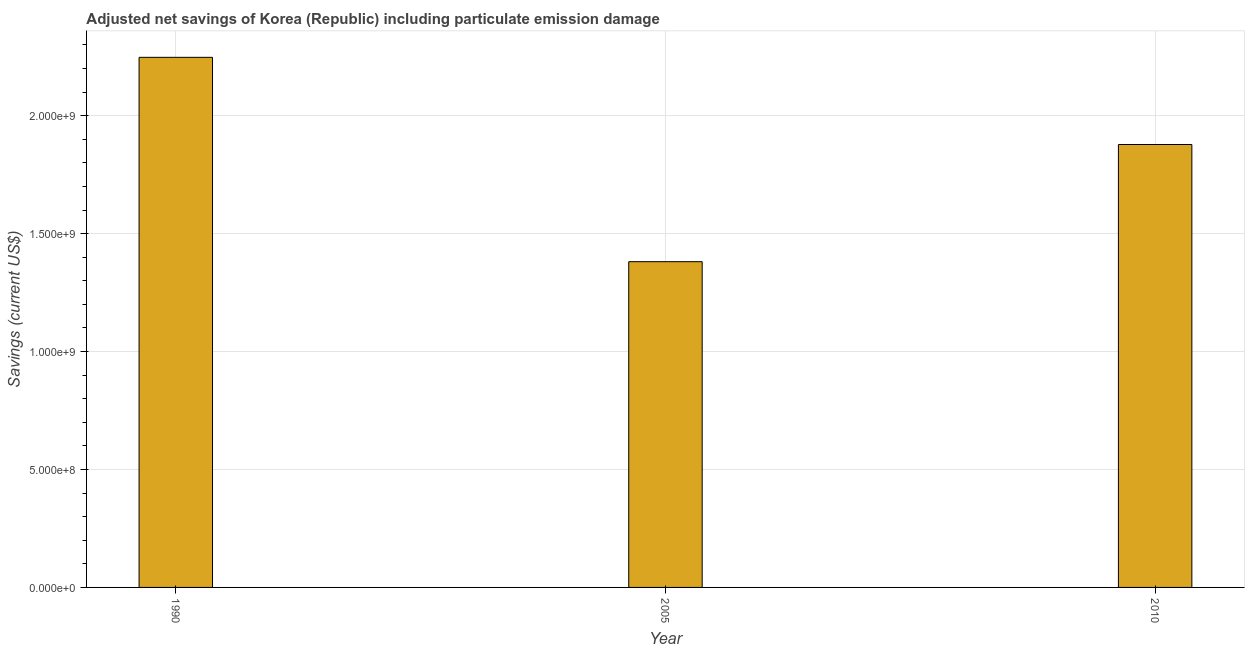Does the graph contain any zero values?
Ensure brevity in your answer.  No. What is the title of the graph?
Offer a very short reply. Adjusted net savings of Korea (Republic) including particulate emission damage. What is the label or title of the Y-axis?
Offer a terse response. Savings (current US$). What is the adjusted net savings in 2010?
Provide a short and direct response. 1.88e+09. Across all years, what is the maximum adjusted net savings?
Provide a succinct answer. 2.25e+09. Across all years, what is the minimum adjusted net savings?
Provide a short and direct response. 1.38e+09. In which year was the adjusted net savings minimum?
Provide a short and direct response. 2005. What is the sum of the adjusted net savings?
Your response must be concise. 5.51e+09. What is the difference between the adjusted net savings in 2005 and 2010?
Your answer should be compact. -4.97e+08. What is the average adjusted net savings per year?
Offer a very short reply. 1.84e+09. What is the median adjusted net savings?
Keep it short and to the point. 1.88e+09. In how many years, is the adjusted net savings greater than 2100000000 US$?
Offer a terse response. 1. What is the ratio of the adjusted net savings in 1990 to that in 2010?
Provide a succinct answer. 1.2. What is the difference between the highest and the second highest adjusted net savings?
Your answer should be compact. 3.70e+08. What is the difference between the highest and the lowest adjusted net savings?
Your answer should be compact. 8.66e+08. How many bars are there?
Provide a succinct answer. 3. Are all the bars in the graph horizontal?
Ensure brevity in your answer.  No. What is the difference between two consecutive major ticks on the Y-axis?
Your answer should be very brief. 5.00e+08. Are the values on the major ticks of Y-axis written in scientific E-notation?
Offer a terse response. Yes. What is the Savings (current US$) in 1990?
Your response must be concise. 2.25e+09. What is the Savings (current US$) of 2005?
Provide a succinct answer. 1.38e+09. What is the Savings (current US$) of 2010?
Offer a very short reply. 1.88e+09. What is the difference between the Savings (current US$) in 1990 and 2005?
Your response must be concise. 8.66e+08. What is the difference between the Savings (current US$) in 1990 and 2010?
Your answer should be compact. 3.70e+08. What is the difference between the Savings (current US$) in 2005 and 2010?
Keep it short and to the point. -4.97e+08. What is the ratio of the Savings (current US$) in 1990 to that in 2005?
Your answer should be compact. 1.63. What is the ratio of the Savings (current US$) in 1990 to that in 2010?
Your answer should be very brief. 1.2. What is the ratio of the Savings (current US$) in 2005 to that in 2010?
Keep it short and to the point. 0.73. 